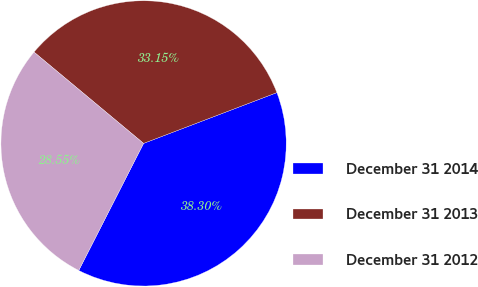Convert chart to OTSL. <chart><loc_0><loc_0><loc_500><loc_500><pie_chart><fcel>December 31 2014<fcel>December 31 2013<fcel>December 31 2012<nl><fcel>38.3%<fcel>33.15%<fcel>28.55%<nl></chart> 